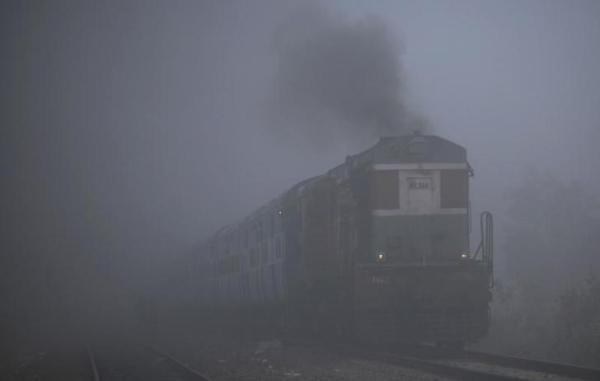How many unicorns would there be in the image now that no more unicorn has been moved to the scene? Although the question asks about unicorns, they are mythical creatures and would not be present in any real-world setting like the one depicted in this image of a train in a foggy environment. Hence, the answer remains 0. 